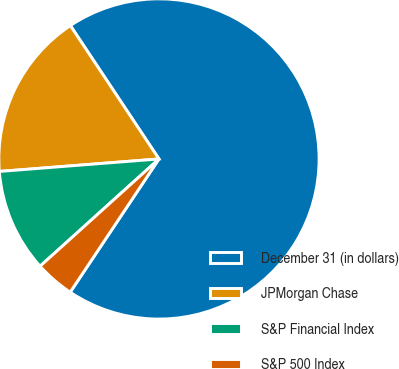Convert chart to OTSL. <chart><loc_0><loc_0><loc_500><loc_500><pie_chart><fcel>December 31 (in dollars)<fcel>JPMorgan Chase<fcel>S&P Financial Index<fcel>S&P 500 Index<nl><fcel>68.69%<fcel>16.91%<fcel>10.44%<fcel>3.96%<nl></chart> 